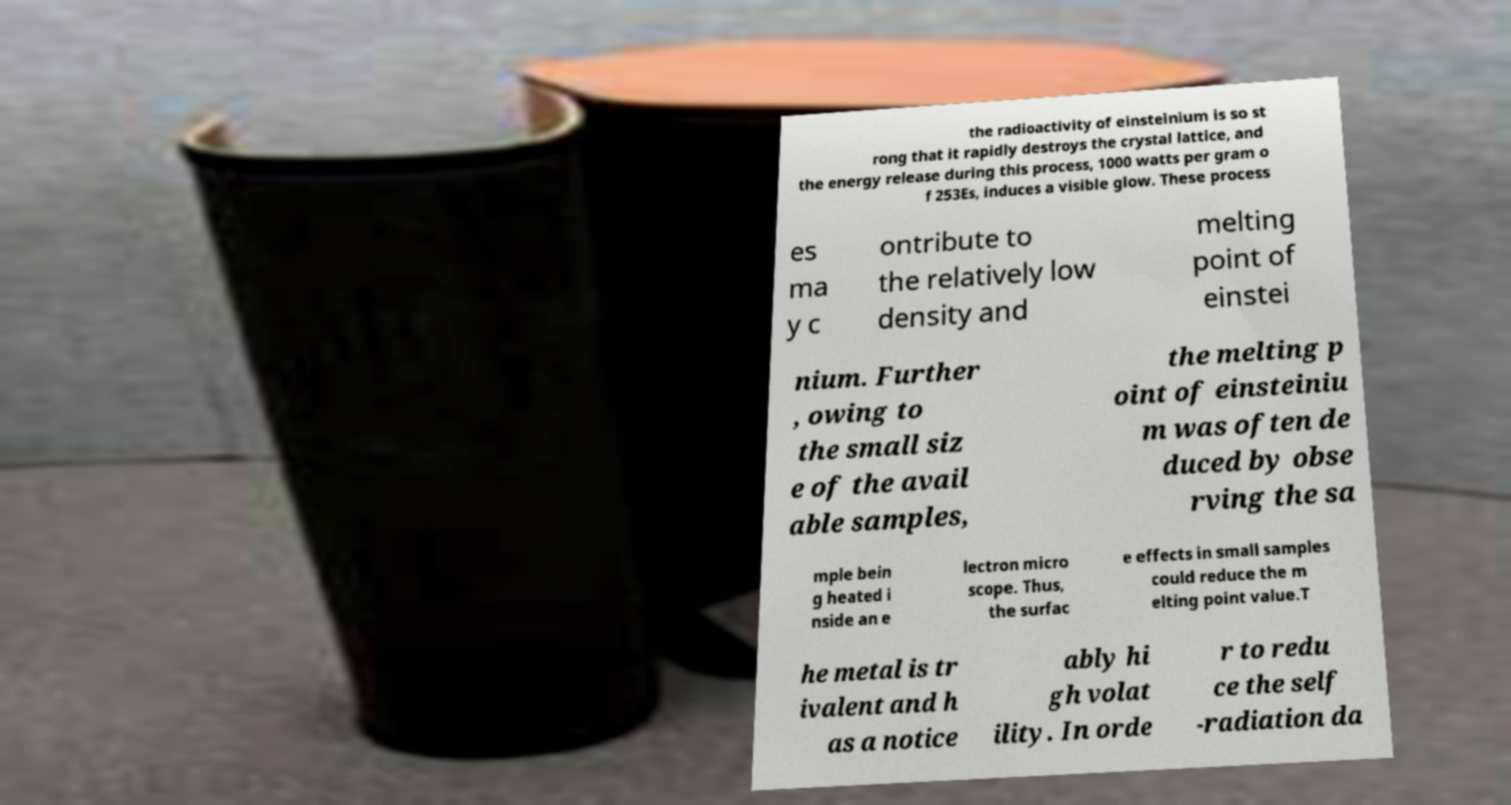Can you accurately transcribe the text from the provided image for me? the radioactivity of einsteinium is so st rong that it rapidly destroys the crystal lattice, and the energy release during this process, 1000 watts per gram o f 253Es, induces a visible glow. These process es ma y c ontribute to the relatively low density and melting point of einstei nium. Further , owing to the small siz e of the avail able samples, the melting p oint of einsteiniu m was often de duced by obse rving the sa mple bein g heated i nside an e lectron micro scope. Thus, the surfac e effects in small samples could reduce the m elting point value.T he metal is tr ivalent and h as a notice ably hi gh volat ility. In orde r to redu ce the self -radiation da 